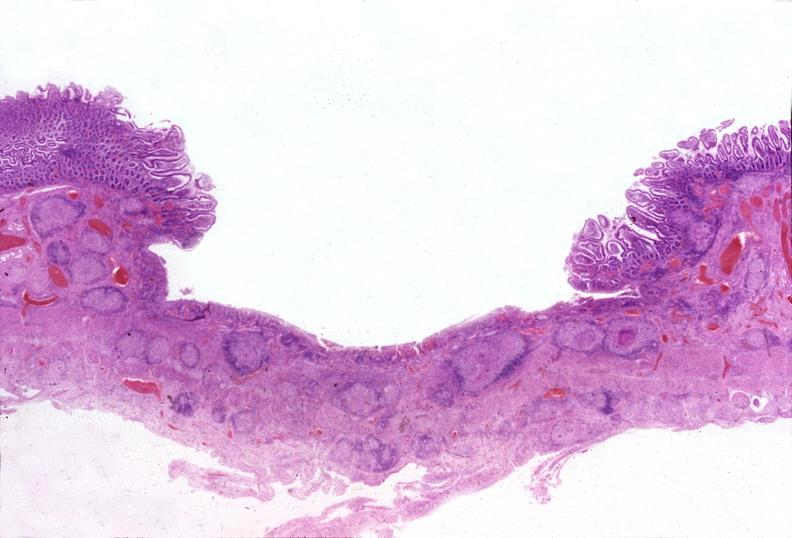does this image show small intestine, tuberculous ileitis?
Answer the question using a single word or phrase. Yes 